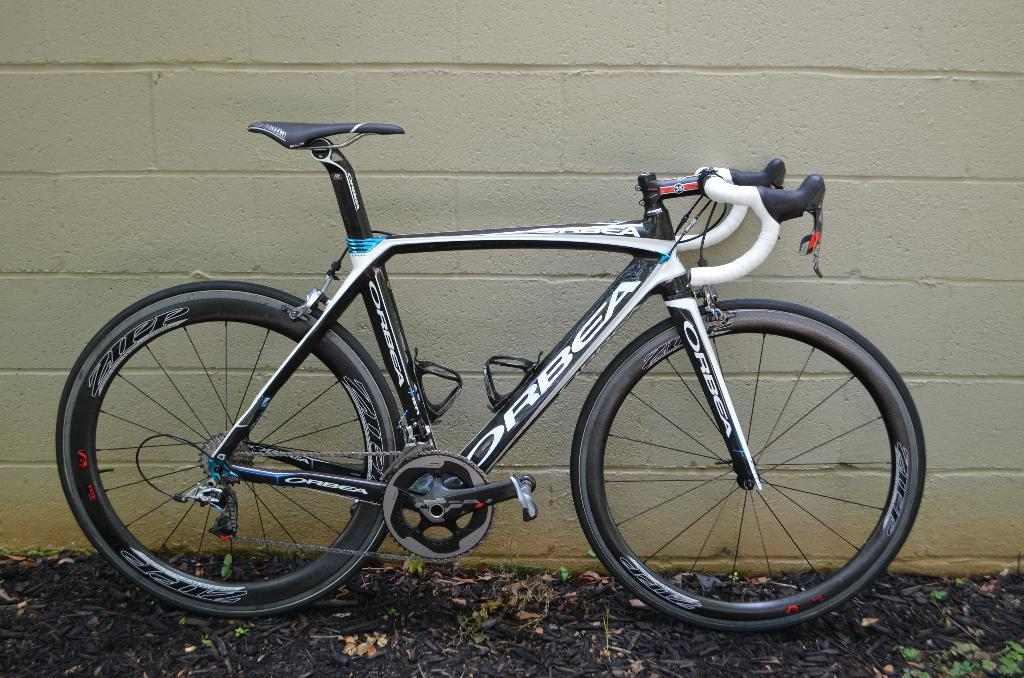What is the main object in the image? There is a bicycle in the image. Where is the bicycle located? The bicycle is parked near a wall. What can be seen at the bottom of the image? Many leaves are visible at the bottom of the image. What type of sofa is visible in the image? There is no sofa present in the image; it features a bicycle parked near a wall and leaves at the bottom. 